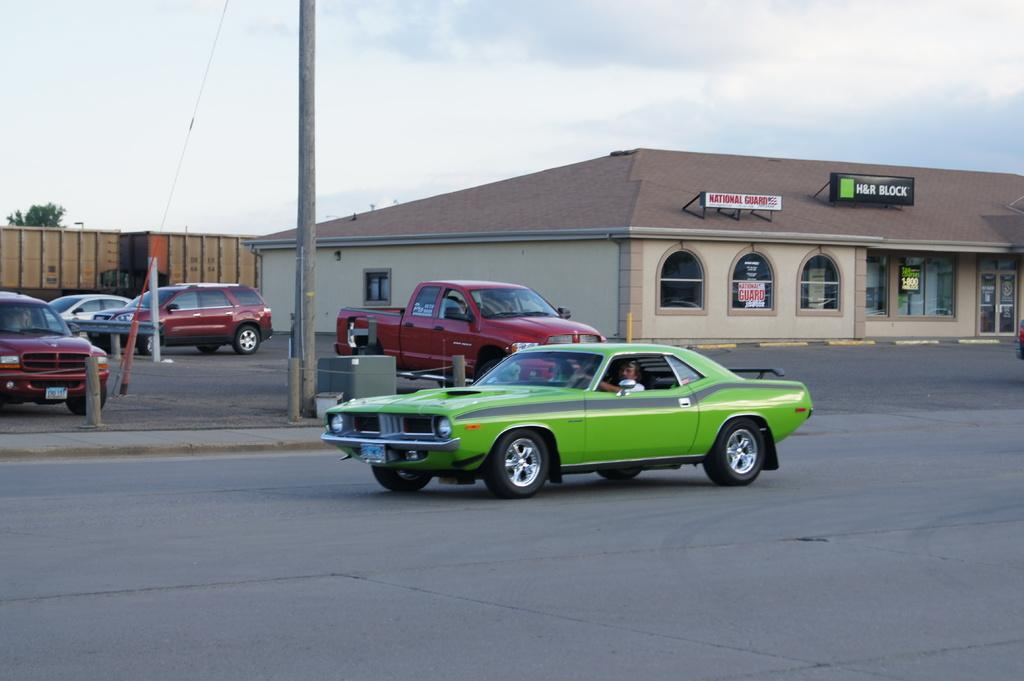What can be seen in the sky in the image? The sky with clouds is visible in the image. What type of structures are present along the street in the image? There are street poles and buildings visible in the image. What are the containers used for in the image? The purpose of the containers is not specified, but they are present in the image. What type of signs can be seen in the image? Name boards are in the image. What type of transportation is on the road in the image? Motor vehicles are on the road in the image. What type of brake can be seen on the motor vehicles in the image? There is no mention of a brake in the image. 